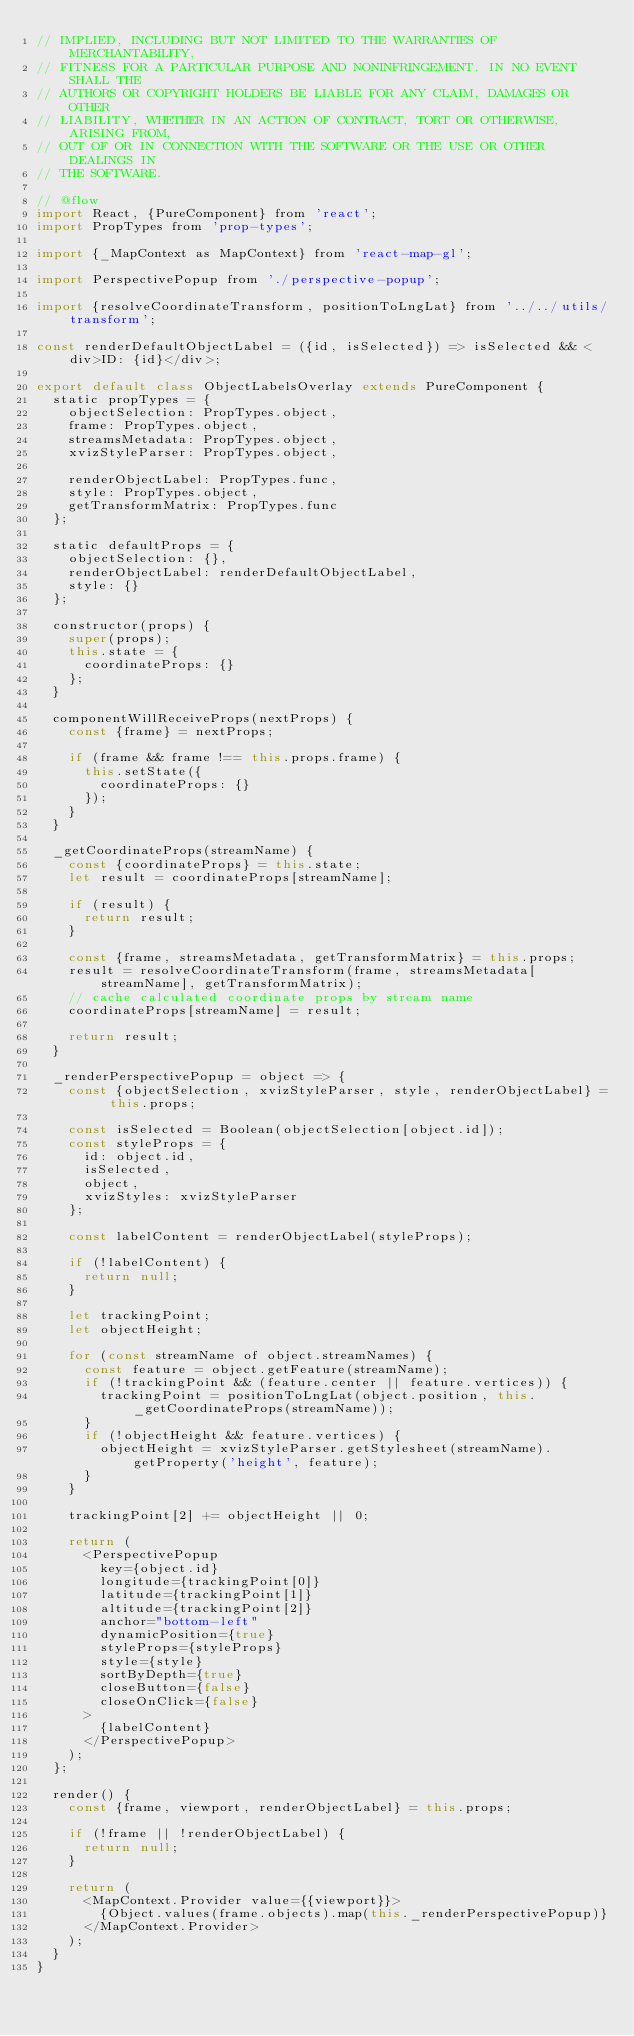<code> <loc_0><loc_0><loc_500><loc_500><_JavaScript_>// IMPLIED, INCLUDING BUT NOT LIMITED TO THE WARRANTIES OF MERCHANTABILITY,
// FITNESS FOR A PARTICULAR PURPOSE AND NONINFRINGEMENT. IN NO EVENT SHALL THE
// AUTHORS OR COPYRIGHT HOLDERS BE LIABLE FOR ANY CLAIM, DAMAGES OR OTHER
// LIABILITY, WHETHER IN AN ACTION OF CONTRACT, TORT OR OTHERWISE, ARISING FROM,
// OUT OF OR IN CONNECTION WITH THE SOFTWARE OR THE USE OR OTHER DEALINGS IN
// THE SOFTWARE.

// @flow
import React, {PureComponent} from 'react';
import PropTypes from 'prop-types';

import {_MapContext as MapContext} from 'react-map-gl';

import PerspectivePopup from './perspective-popup';

import {resolveCoordinateTransform, positionToLngLat} from '../../utils/transform';

const renderDefaultObjectLabel = ({id, isSelected}) => isSelected && <div>ID: {id}</div>;

export default class ObjectLabelsOverlay extends PureComponent {
  static propTypes = {
    objectSelection: PropTypes.object,
    frame: PropTypes.object,
    streamsMetadata: PropTypes.object,
    xvizStyleParser: PropTypes.object,

    renderObjectLabel: PropTypes.func,
    style: PropTypes.object,
    getTransformMatrix: PropTypes.func
  };

  static defaultProps = {
    objectSelection: {},
    renderObjectLabel: renderDefaultObjectLabel,
    style: {}
  };

  constructor(props) {
    super(props);
    this.state = {
      coordinateProps: {}
    };
  }

  componentWillReceiveProps(nextProps) {
    const {frame} = nextProps;

    if (frame && frame !== this.props.frame) {
      this.setState({
        coordinateProps: {}
      });
    }
  }

  _getCoordinateProps(streamName) {
    const {coordinateProps} = this.state;
    let result = coordinateProps[streamName];

    if (result) {
      return result;
    }

    const {frame, streamsMetadata, getTransformMatrix} = this.props;
    result = resolveCoordinateTransform(frame, streamsMetadata[streamName], getTransformMatrix);
    // cache calculated coordinate props by stream name
    coordinateProps[streamName] = result;

    return result;
  }

  _renderPerspectivePopup = object => {
    const {objectSelection, xvizStyleParser, style, renderObjectLabel} = this.props;

    const isSelected = Boolean(objectSelection[object.id]);
    const styleProps = {
      id: object.id,
      isSelected,
      object,
      xvizStyles: xvizStyleParser
    };

    const labelContent = renderObjectLabel(styleProps);

    if (!labelContent) {
      return null;
    }

    let trackingPoint;
    let objectHeight;

    for (const streamName of object.streamNames) {
      const feature = object.getFeature(streamName);
      if (!trackingPoint && (feature.center || feature.vertices)) {
        trackingPoint = positionToLngLat(object.position, this._getCoordinateProps(streamName));
      }
      if (!objectHeight && feature.vertices) {
        objectHeight = xvizStyleParser.getStylesheet(streamName).getProperty('height', feature);
      }
    }

    trackingPoint[2] += objectHeight || 0;

    return (
      <PerspectivePopup
        key={object.id}
        longitude={trackingPoint[0]}
        latitude={trackingPoint[1]}
        altitude={trackingPoint[2]}
        anchor="bottom-left"
        dynamicPosition={true}
        styleProps={styleProps}
        style={style}
        sortByDepth={true}
        closeButton={false}
        closeOnClick={false}
      >
        {labelContent}
      </PerspectivePopup>
    );
  };

  render() {
    const {frame, viewport, renderObjectLabel} = this.props;

    if (!frame || !renderObjectLabel) {
      return null;
    }

    return (
      <MapContext.Provider value={{viewport}}>
        {Object.values(frame.objects).map(this._renderPerspectivePopup)}
      </MapContext.Provider>
    );
  }
}
</code> 